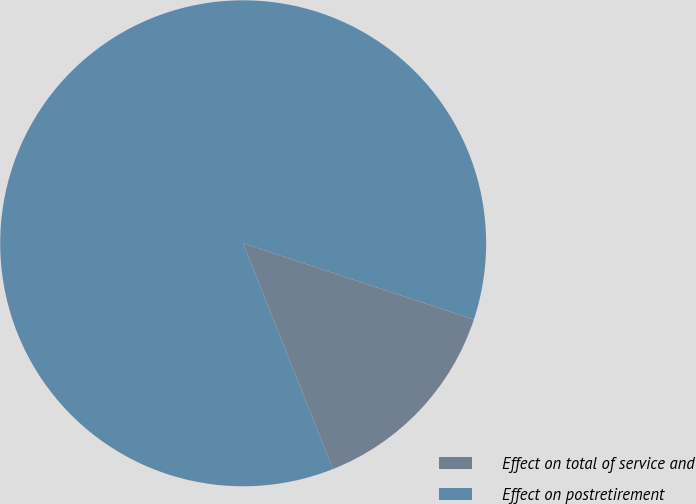Convert chart. <chart><loc_0><loc_0><loc_500><loc_500><pie_chart><fcel>Effect on total of service and<fcel>Effect on postretirement<nl><fcel>13.89%<fcel>86.11%<nl></chart> 